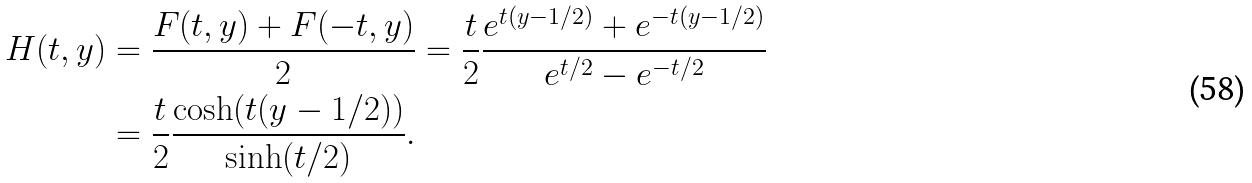<formula> <loc_0><loc_0><loc_500><loc_500>H ( t , y ) & = \frac { F ( t , y ) + F ( - t , y ) } { 2 } = \frac { t } { 2 } \frac { e ^ { t ( y - 1 / 2 ) } + e ^ { - t ( y - 1 / 2 ) } } { e ^ { t / 2 } - e ^ { - t / 2 } } \\ & = \frac { t } { 2 } \frac { \cosh ( t ( y - 1 / 2 ) ) } { \sinh ( t / 2 ) } .</formula> 